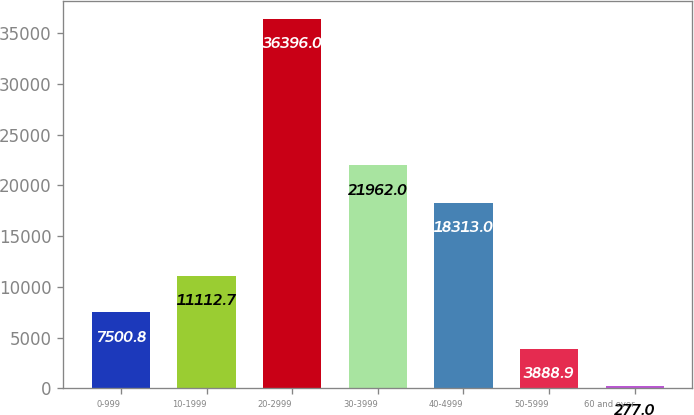Convert chart to OTSL. <chart><loc_0><loc_0><loc_500><loc_500><bar_chart><fcel>0-999<fcel>10-1999<fcel>20-2999<fcel>30-3999<fcel>40-4999<fcel>50-5999<fcel>60 and over<nl><fcel>7500.8<fcel>11112.7<fcel>36396<fcel>21962<fcel>18313<fcel>3888.9<fcel>277<nl></chart> 